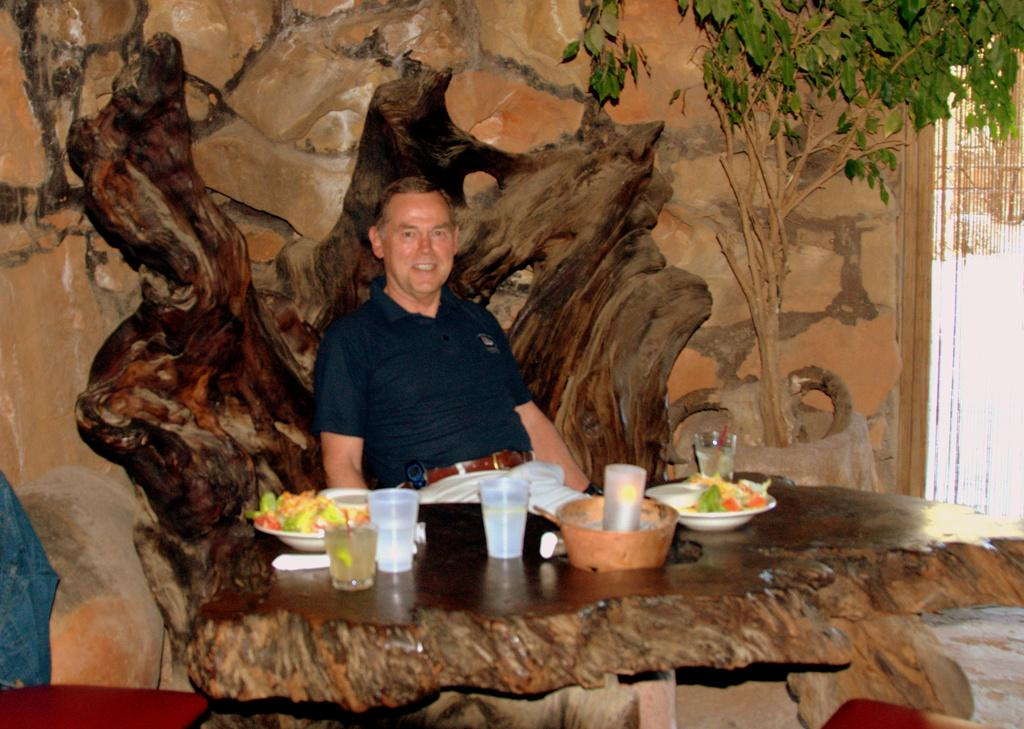What is the man in the image sitting on? The man is sitting in a wooden chair. What objects are on the table in the image? There are glasses, plates, food, a bowl, and straws on the table. What can be seen in the background of the image? There is a wall or wall poster and a tree visible in the background. What type of lipstick is the man wearing in the image? The man is not wearing lipstick in the image, as it is not a cosmetic product typically worn by men. 